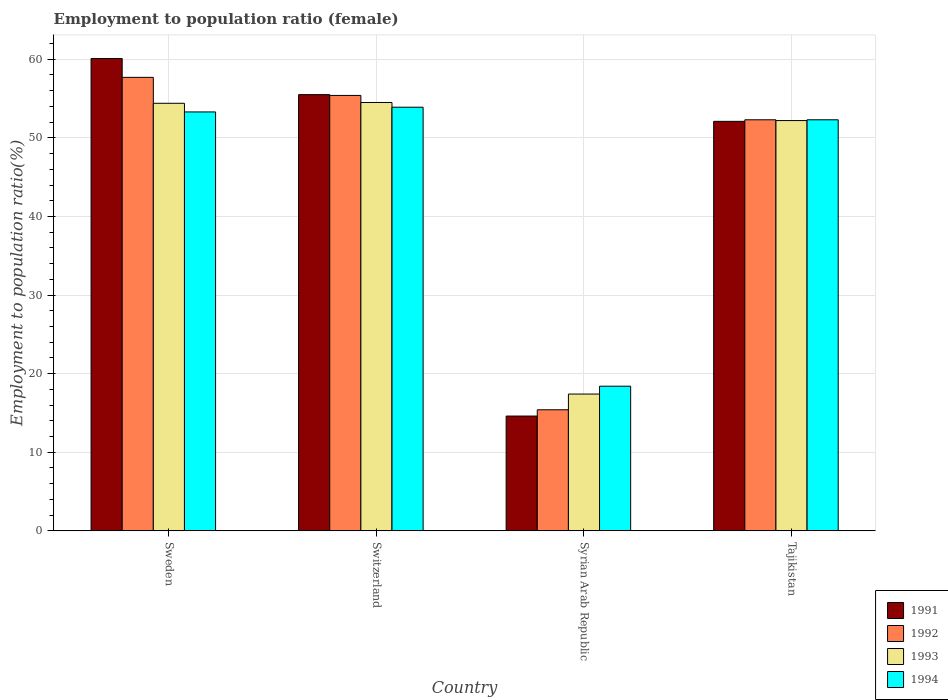Are the number of bars on each tick of the X-axis equal?
Your response must be concise. Yes. How many bars are there on the 2nd tick from the left?
Keep it short and to the point. 4. How many bars are there on the 4th tick from the right?
Give a very brief answer. 4. What is the label of the 3rd group of bars from the left?
Give a very brief answer. Syrian Arab Republic. What is the employment to population ratio in 1994 in Syrian Arab Republic?
Your answer should be very brief. 18.4. Across all countries, what is the maximum employment to population ratio in 1993?
Make the answer very short. 54.5. Across all countries, what is the minimum employment to population ratio in 1994?
Offer a very short reply. 18.4. In which country was the employment to population ratio in 1991 maximum?
Provide a succinct answer. Sweden. In which country was the employment to population ratio in 1994 minimum?
Offer a terse response. Syrian Arab Republic. What is the total employment to population ratio in 1991 in the graph?
Offer a very short reply. 182.3. What is the difference between the employment to population ratio in 1991 in Sweden and that in Tajikistan?
Ensure brevity in your answer.  8. What is the difference between the employment to population ratio in 1994 in Switzerland and the employment to population ratio in 1992 in Syrian Arab Republic?
Ensure brevity in your answer.  38.5. What is the average employment to population ratio in 1993 per country?
Provide a succinct answer. 44.63. What is the difference between the employment to population ratio of/in 1992 and employment to population ratio of/in 1991 in Syrian Arab Republic?
Ensure brevity in your answer.  0.8. What is the ratio of the employment to population ratio in 1991 in Sweden to that in Syrian Arab Republic?
Keep it short and to the point. 4.12. Is the employment to population ratio in 1994 in Sweden less than that in Syrian Arab Republic?
Give a very brief answer. No. Is the difference between the employment to population ratio in 1992 in Sweden and Switzerland greater than the difference between the employment to population ratio in 1991 in Sweden and Switzerland?
Keep it short and to the point. No. What is the difference between the highest and the lowest employment to population ratio in 1991?
Provide a short and direct response. 45.5. Is it the case that in every country, the sum of the employment to population ratio in 1992 and employment to population ratio in 1991 is greater than the sum of employment to population ratio in 1993 and employment to population ratio in 1994?
Keep it short and to the point. No. What does the 3rd bar from the right in Sweden represents?
Offer a very short reply. 1992. Is it the case that in every country, the sum of the employment to population ratio in 1991 and employment to population ratio in 1993 is greater than the employment to population ratio in 1994?
Keep it short and to the point. Yes. Are all the bars in the graph horizontal?
Your answer should be compact. No. What is the difference between two consecutive major ticks on the Y-axis?
Make the answer very short. 10. Are the values on the major ticks of Y-axis written in scientific E-notation?
Offer a very short reply. No. Does the graph contain any zero values?
Ensure brevity in your answer.  No. Where does the legend appear in the graph?
Your answer should be compact. Bottom right. How many legend labels are there?
Keep it short and to the point. 4. How are the legend labels stacked?
Make the answer very short. Vertical. What is the title of the graph?
Provide a short and direct response. Employment to population ratio (female). Does "1983" appear as one of the legend labels in the graph?
Keep it short and to the point. No. What is the label or title of the X-axis?
Your answer should be very brief. Country. What is the label or title of the Y-axis?
Provide a short and direct response. Employment to population ratio(%). What is the Employment to population ratio(%) in 1991 in Sweden?
Offer a terse response. 60.1. What is the Employment to population ratio(%) in 1992 in Sweden?
Ensure brevity in your answer.  57.7. What is the Employment to population ratio(%) of 1993 in Sweden?
Make the answer very short. 54.4. What is the Employment to population ratio(%) in 1994 in Sweden?
Your answer should be very brief. 53.3. What is the Employment to population ratio(%) in 1991 in Switzerland?
Give a very brief answer. 55.5. What is the Employment to population ratio(%) of 1992 in Switzerland?
Offer a very short reply. 55.4. What is the Employment to population ratio(%) in 1993 in Switzerland?
Your answer should be compact. 54.5. What is the Employment to population ratio(%) in 1994 in Switzerland?
Keep it short and to the point. 53.9. What is the Employment to population ratio(%) of 1991 in Syrian Arab Republic?
Give a very brief answer. 14.6. What is the Employment to population ratio(%) of 1992 in Syrian Arab Republic?
Ensure brevity in your answer.  15.4. What is the Employment to population ratio(%) in 1993 in Syrian Arab Republic?
Provide a succinct answer. 17.4. What is the Employment to population ratio(%) of 1994 in Syrian Arab Republic?
Your answer should be very brief. 18.4. What is the Employment to population ratio(%) in 1991 in Tajikistan?
Ensure brevity in your answer.  52.1. What is the Employment to population ratio(%) of 1992 in Tajikistan?
Your answer should be compact. 52.3. What is the Employment to population ratio(%) in 1993 in Tajikistan?
Offer a terse response. 52.2. What is the Employment to population ratio(%) in 1994 in Tajikistan?
Ensure brevity in your answer.  52.3. Across all countries, what is the maximum Employment to population ratio(%) in 1991?
Provide a succinct answer. 60.1. Across all countries, what is the maximum Employment to population ratio(%) in 1992?
Offer a terse response. 57.7. Across all countries, what is the maximum Employment to population ratio(%) in 1993?
Your answer should be very brief. 54.5. Across all countries, what is the maximum Employment to population ratio(%) of 1994?
Keep it short and to the point. 53.9. Across all countries, what is the minimum Employment to population ratio(%) in 1991?
Provide a short and direct response. 14.6. Across all countries, what is the minimum Employment to population ratio(%) in 1992?
Keep it short and to the point. 15.4. Across all countries, what is the minimum Employment to population ratio(%) of 1993?
Your answer should be compact. 17.4. Across all countries, what is the minimum Employment to population ratio(%) of 1994?
Ensure brevity in your answer.  18.4. What is the total Employment to population ratio(%) of 1991 in the graph?
Give a very brief answer. 182.3. What is the total Employment to population ratio(%) in 1992 in the graph?
Offer a very short reply. 180.8. What is the total Employment to population ratio(%) of 1993 in the graph?
Offer a terse response. 178.5. What is the total Employment to population ratio(%) in 1994 in the graph?
Give a very brief answer. 177.9. What is the difference between the Employment to population ratio(%) of 1992 in Sweden and that in Switzerland?
Make the answer very short. 2.3. What is the difference between the Employment to population ratio(%) of 1993 in Sweden and that in Switzerland?
Your answer should be compact. -0.1. What is the difference between the Employment to population ratio(%) of 1994 in Sweden and that in Switzerland?
Provide a short and direct response. -0.6. What is the difference between the Employment to population ratio(%) in 1991 in Sweden and that in Syrian Arab Republic?
Your response must be concise. 45.5. What is the difference between the Employment to population ratio(%) in 1992 in Sweden and that in Syrian Arab Republic?
Offer a very short reply. 42.3. What is the difference between the Employment to population ratio(%) of 1993 in Sweden and that in Syrian Arab Republic?
Your answer should be compact. 37. What is the difference between the Employment to population ratio(%) in 1994 in Sweden and that in Syrian Arab Republic?
Give a very brief answer. 34.9. What is the difference between the Employment to population ratio(%) in 1991 in Sweden and that in Tajikistan?
Provide a short and direct response. 8. What is the difference between the Employment to population ratio(%) of 1991 in Switzerland and that in Syrian Arab Republic?
Your answer should be compact. 40.9. What is the difference between the Employment to population ratio(%) in 1993 in Switzerland and that in Syrian Arab Republic?
Ensure brevity in your answer.  37.1. What is the difference between the Employment to population ratio(%) in 1994 in Switzerland and that in Syrian Arab Republic?
Keep it short and to the point. 35.5. What is the difference between the Employment to population ratio(%) in 1991 in Switzerland and that in Tajikistan?
Keep it short and to the point. 3.4. What is the difference between the Employment to population ratio(%) in 1992 in Switzerland and that in Tajikistan?
Offer a terse response. 3.1. What is the difference between the Employment to population ratio(%) in 1993 in Switzerland and that in Tajikistan?
Offer a very short reply. 2.3. What is the difference between the Employment to population ratio(%) in 1991 in Syrian Arab Republic and that in Tajikistan?
Offer a terse response. -37.5. What is the difference between the Employment to population ratio(%) of 1992 in Syrian Arab Republic and that in Tajikistan?
Your response must be concise. -36.9. What is the difference between the Employment to population ratio(%) of 1993 in Syrian Arab Republic and that in Tajikistan?
Keep it short and to the point. -34.8. What is the difference between the Employment to population ratio(%) of 1994 in Syrian Arab Republic and that in Tajikistan?
Provide a succinct answer. -33.9. What is the difference between the Employment to population ratio(%) of 1991 in Sweden and the Employment to population ratio(%) of 1992 in Syrian Arab Republic?
Keep it short and to the point. 44.7. What is the difference between the Employment to population ratio(%) in 1991 in Sweden and the Employment to population ratio(%) in 1993 in Syrian Arab Republic?
Your answer should be very brief. 42.7. What is the difference between the Employment to population ratio(%) of 1991 in Sweden and the Employment to population ratio(%) of 1994 in Syrian Arab Republic?
Offer a very short reply. 41.7. What is the difference between the Employment to population ratio(%) of 1992 in Sweden and the Employment to population ratio(%) of 1993 in Syrian Arab Republic?
Your answer should be compact. 40.3. What is the difference between the Employment to population ratio(%) of 1992 in Sweden and the Employment to population ratio(%) of 1994 in Syrian Arab Republic?
Your response must be concise. 39.3. What is the difference between the Employment to population ratio(%) of 1991 in Sweden and the Employment to population ratio(%) of 1993 in Tajikistan?
Your response must be concise. 7.9. What is the difference between the Employment to population ratio(%) in 1991 in Switzerland and the Employment to population ratio(%) in 1992 in Syrian Arab Republic?
Keep it short and to the point. 40.1. What is the difference between the Employment to population ratio(%) of 1991 in Switzerland and the Employment to population ratio(%) of 1993 in Syrian Arab Republic?
Keep it short and to the point. 38.1. What is the difference between the Employment to population ratio(%) of 1991 in Switzerland and the Employment to population ratio(%) of 1994 in Syrian Arab Republic?
Give a very brief answer. 37.1. What is the difference between the Employment to population ratio(%) of 1993 in Switzerland and the Employment to population ratio(%) of 1994 in Syrian Arab Republic?
Provide a succinct answer. 36.1. What is the difference between the Employment to population ratio(%) of 1991 in Switzerland and the Employment to population ratio(%) of 1994 in Tajikistan?
Provide a succinct answer. 3.2. What is the difference between the Employment to population ratio(%) in 1993 in Switzerland and the Employment to population ratio(%) in 1994 in Tajikistan?
Your answer should be very brief. 2.2. What is the difference between the Employment to population ratio(%) in 1991 in Syrian Arab Republic and the Employment to population ratio(%) in 1992 in Tajikistan?
Your response must be concise. -37.7. What is the difference between the Employment to population ratio(%) in 1991 in Syrian Arab Republic and the Employment to population ratio(%) in 1993 in Tajikistan?
Your answer should be compact. -37.6. What is the difference between the Employment to population ratio(%) in 1991 in Syrian Arab Republic and the Employment to population ratio(%) in 1994 in Tajikistan?
Give a very brief answer. -37.7. What is the difference between the Employment to population ratio(%) in 1992 in Syrian Arab Republic and the Employment to population ratio(%) in 1993 in Tajikistan?
Offer a very short reply. -36.8. What is the difference between the Employment to population ratio(%) in 1992 in Syrian Arab Republic and the Employment to population ratio(%) in 1994 in Tajikistan?
Your response must be concise. -36.9. What is the difference between the Employment to population ratio(%) of 1993 in Syrian Arab Republic and the Employment to population ratio(%) of 1994 in Tajikistan?
Offer a very short reply. -34.9. What is the average Employment to population ratio(%) in 1991 per country?
Give a very brief answer. 45.58. What is the average Employment to population ratio(%) of 1992 per country?
Your answer should be compact. 45.2. What is the average Employment to population ratio(%) in 1993 per country?
Your answer should be very brief. 44.62. What is the average Employment to population ratio(%) in 1994 per country?
Your answer should be compact. 44.48. What is the difference between the Employment to population ratio(%) of 1991 and Employment to population ratio(%) of 1993 in Sweden?
Provide a succinct answer. 5.7. What is the difference between the Employment to population ratio(%) of 1992 and Employment to population ratio(%) of 1993 in Sweden?
Offer a very short reply. 3.3. What is the difference between the Employment to population ratio(%) of 1992 and Employment to population ratio(%) of 1994 in Sweden?
Ensure brevity in your answer.  4.4. What is the difference between the Employment to population ratio(%) in 1993 and Employment to population ratio(%) in 1994 in Sweden?
Your answer should be compact. 1.1. What is the difference between the Employment to population ratio(%) in 1991 and Employment to population ratio(%) in 1992 in Switzerland?
Give a very brief answer. 0.1. What is the difference between the Employment to population ratio(%) of 1991 and Employment to population ratio(%) of 1993 in Switzerland?
Make the answer very short. 1. What is the difference between the Employment to population ratio(%) in 1991 and Employment to population ratio(%) in 1993 in Syrian Arab Republic?
Keep it short and to the point. -2.8. What is the difference between the Employment to population ratio(%) in 1992 and Employment to population ratio(%) in 1993 in Syrian Arab Republic?
Ensure brevity in your answer.  -2. What is the difference between the Employment to population ratio(%) in 1991 and Employment to population ratio(%) in 1992 in Tajikistan?
Offer a terse response. -0.2. What is the difference between the Employment to population ratio(%) in 1991 and Employment to population ratio(%) in 1993 in Tajikistan?
Offer a terse response. -0.1. What is the difference between the Employment to population ratio(%) of 1991 and Employment to population ratio(%) of 1994 in Tajikistan?
Ensure brevity in your answer.  -0.2. What is the difference between the Employment to population ratio(%) in 1992 and Employment to population ratio(%) in 1993 in Tajikistan?
Ensure brevity in your answer.  0.1. What is the difference between the Employment to population ratio(%) of 1992 and Employment to population ratio(%) of 1994 in Tajikistan?
Give a very brief answer. 0. What is the difference between the Employment to population ratio(%) of 1993 and Employment to population ratio(%) of 1994 in Tajikistan?
Keep it short and to the point. -0.1. What is the ratio of the Employment to population ratio(%) of 1991 in Sweden to that in Switzerland?
Offer a terse response. 1.08. What is the ratio of the Employment to population ratio(%) in 1992 in Sweden to that in Switzerland?
Make the answer very short. 1.04. What is the ratio of the Employment to population ratio(%) in 1994 in Sweden to that in Switzerland?
Give a very brief answer. 0.99. What is the ratio of the Employment to population ratio(%) in 1991 in Sweden to that in Syrian Arab Republic?
Offer a very short reply. 4.12. What is the ratio of the Employment to population ratio(%) in 1992 in Sweden to that in Syrian Arab Republic?
Ensure brevity in your answer.  3.75. What is the ratio of the Employment to population ratio(%) of 1993 in Sweden to that in Syrian Arab Republic?
Provide a succinct answer. 3.13. What is the ratio of the Employment to population ratio(%) in 1994 in Sweden to that in Syrian Arab Republic?
Your answer should be compact. 2.9. What is the ratio of the Employment to population ratio(%) in 1991 in Sweden to that in Tajikistan?
Offer a very short reply. 1.15. What is the ratio of the Employment to population ratio(%) in 1992 in Sweden to that in Tajikistan?
Provide a short and direct response. 1.1. What is the ratio of the Employment to population ratio(%) of 1993 in Sweden to that in Tajikistan?
Your answer should be compact. 1.04. What is the ratio of the Employment to population ratio(%) of 1994 in Sweden to that in Tajikistan?
Your response must be concise. 1.02. What is the ratio of the Employment to population ratio(%) in 1991 in Switzerland to that in Syrian Arab Republic?
Provide a short and direct response. 3.8. What is the ratio of the Employment to population ratio(%) in 1992 in Switzerland to that in Syrian Arab Republic?
Your answer should be very brief. 3.6. What is the ratio of the Employment to population ratio(%) of 1993 in Switzerland to that in Syrian Arab Republic?
Provide a succinct answer. 3.13. What is the ratio of the Employment to population ratio(%) in 1994 in Switzerland to that in Syrian Arab Republic?
Your response must be concise. 2.93. What is the ratio of the Employment to population ratio(%) in 1991 in Switzerland to that in Tajikistan?
Make the answer very short. 1.07. What is the ratio of the Employment to population ratio(%) of 1992 in Switzerland to that in Tajikistan?
Keep it short and to the point. 1.06. What is the ratio of the Employment to population ratio(%) of 1993 in Switzerland to that in Tajikistan?
Keep it short and to the point. 1.04. What is the ratio of the Employment to population ratio(%) of 1994 in Switzerland to that in Tajikistan?
Your answer should be compact. 1.03. What is the ratio of the Employment to population ratio(%) of 1991 in Syrian Arab Republic to that in Tajikistan?
Make the answer very short. 0.28. What is the ratio of the Employment to population ratio(%) in 1992 in Syrian Arab Republic to that in Tajikistan?
Keep it short and to the point. 0.29. What is the ratio of the Employment to population ratio(%) of 1993 in Syrian Arab Republic to that in Tajikistan?
Give a very brief answer. 0.33. What is the ratio of the Employment to population ratio(%) in 1994 in Syrian Arab Republic to that in Tajikistan?
Your response must be concise. 0.35. What is the difference between the highest and the second highest Employment to population ratio(%) of 1991?
Make the answer very short. 4.6. What is the difference between the highest and the second highest Employment to population ratio(%) in 1993?
Ensure brevity in your answer.  0.1. What is the difference between the highest and the lowest Employment to population ratio(%) of 1991?
Your answer should be compact. 45.5. What is the difference between the highest and the lowest Employment to population ratio(%) in 1992?
Give a very brief answer. 42.3. What is the difference between the highest and the lowest Employment to population ratio(%) in 1993?
Make the answer very short. 37.1. What is the difference between the highest and the lowest Employment to population ratio(%) of 1994?
Make the answer very short. 35.5. 